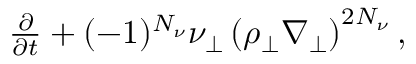<formula> <loc_0><loc_0><loc_500><loc_500>\begin{array} { r } { \frac { \partial } { \partial t } + ( - 1 ) ^ { N _ { \nu } } \nu _ { \perp } \left ( \rho _ { \perp } { \nabla } _ { \perp } \right ) ^ { 2 { N _ { \nu } } } , } \end{array}</formula> 